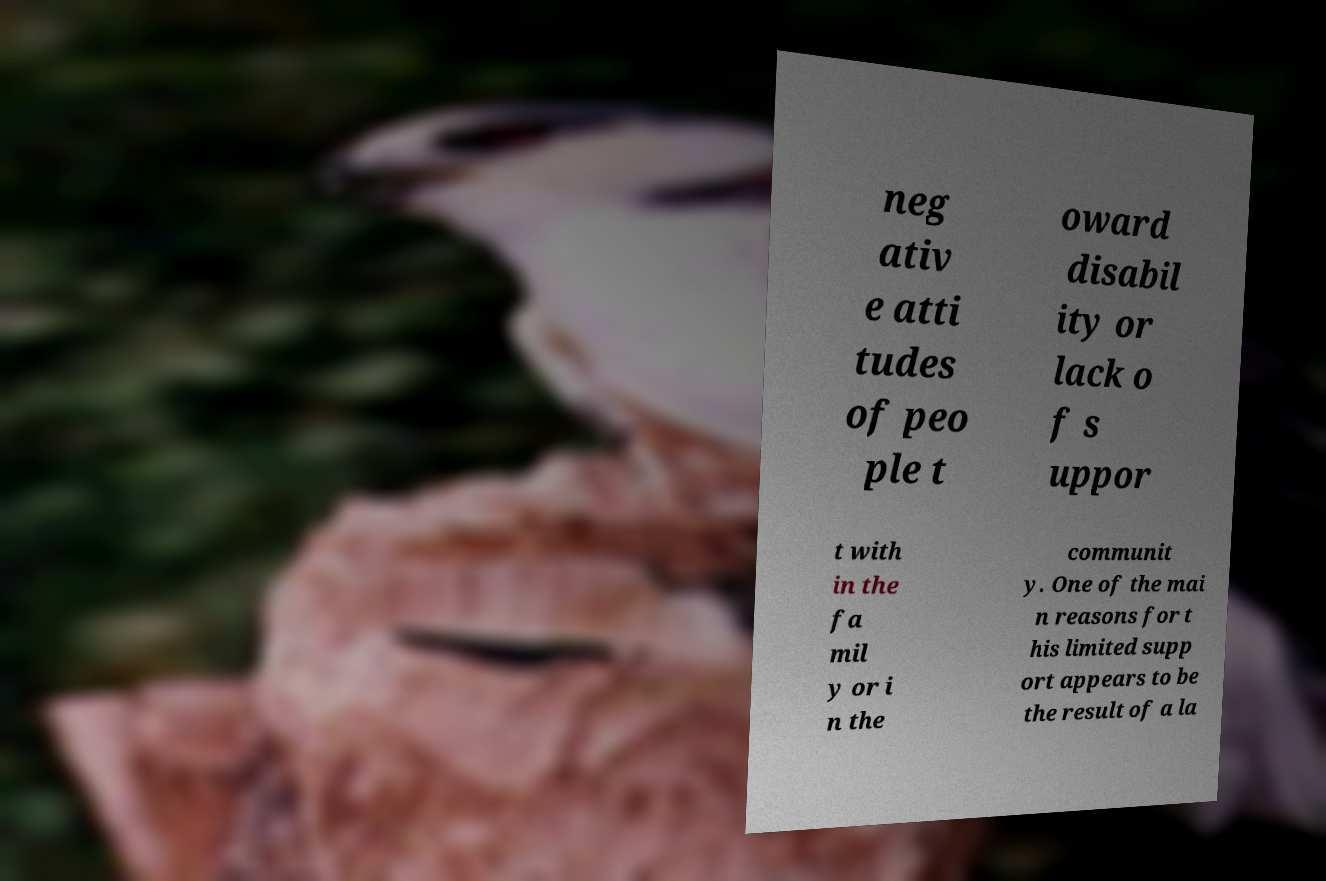There's text embedded in this image that I need extracted. Can you transcribe it verbatim? neg ativ e atti tudes of peo ple t oward disabil ity or lack o f s uppor t with in the fa mil y or i n the communit y. One of the mai n reasons for t his limited supp ort appears to be the result of a la 